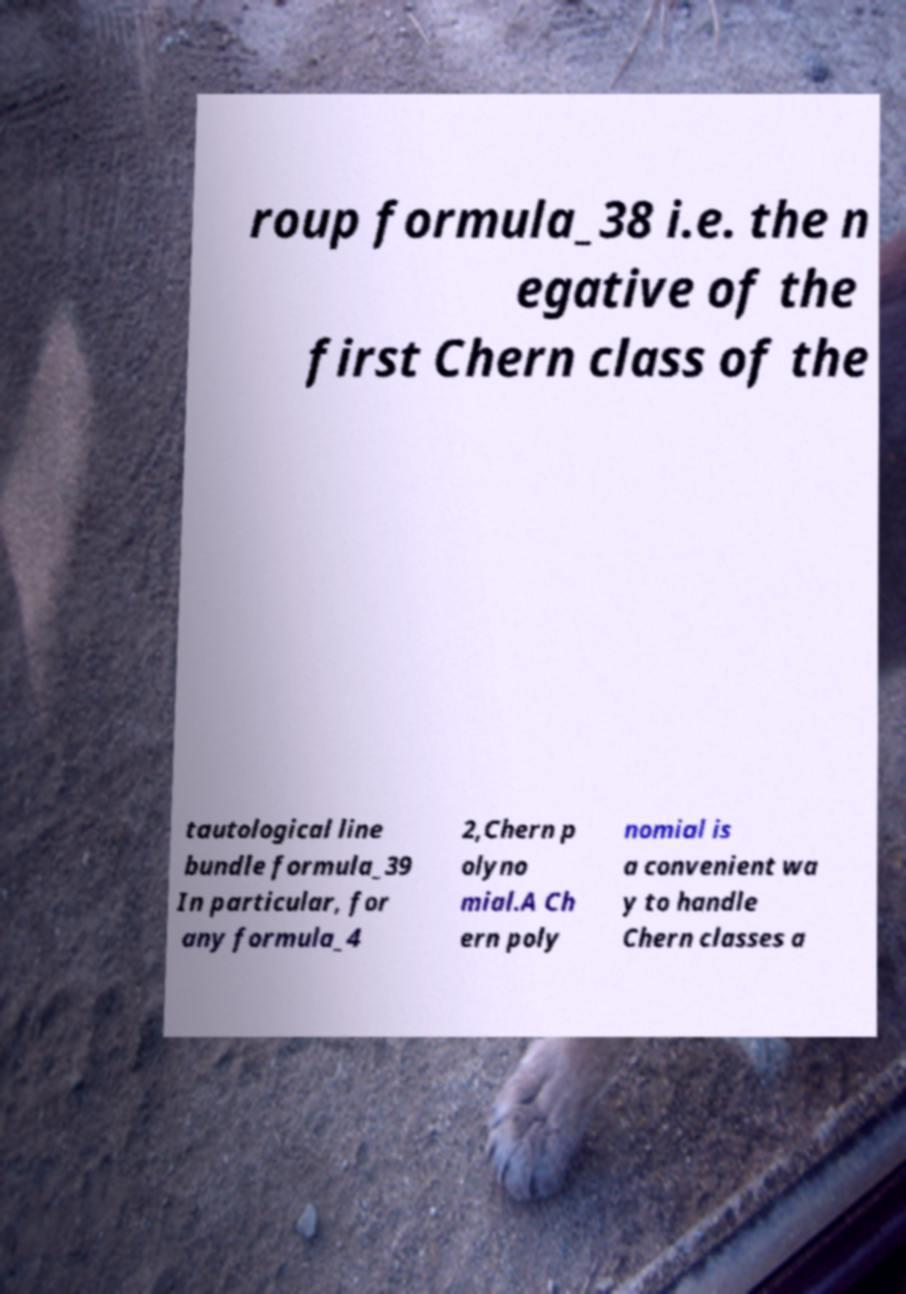Could you assist in decoding the text presented in this image and type it out clearly? roup formula_38 i.e. the n egative of the first Chern class of the tautological line bundle formula_39 In particular, for any formula_4 2,Chern p olyno mial.A Ch ern poly nomial is a convenient wa y to handle Chern classes a 